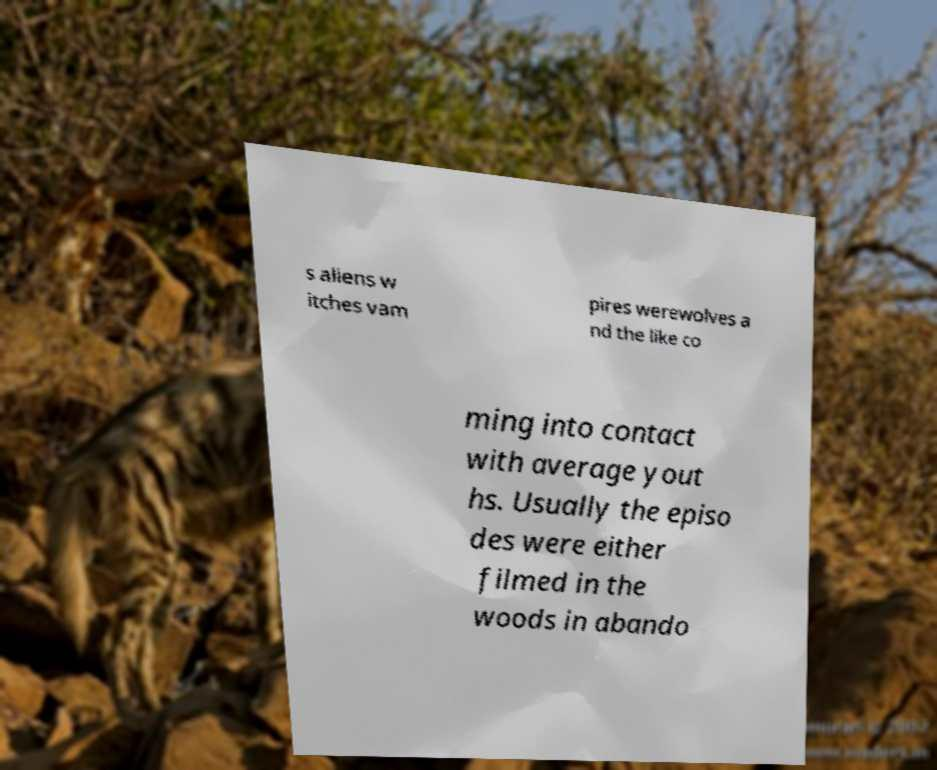Please identify and transcribe the text found in this image. s aliens w itches vam pires werewolves a nd the like co ming into contact with average yout hs. Usually the episo des were either filmed in the woods in abando 